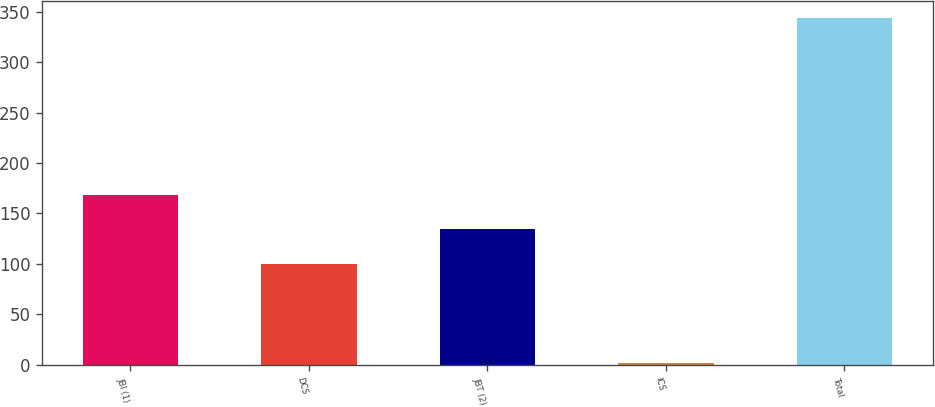Convert chart to OTSL. <chart><loc_0><loc_0><loc_500><loc_500><bar_chart><fcel>JBI (1)<fcel>DCS<fcel>JBT (2)<fcel>ICS<fcel>Total<nl><fcel>168.4<fcel>100<fcel>134.2<fcel>2<fcel>344<nl></chart> 